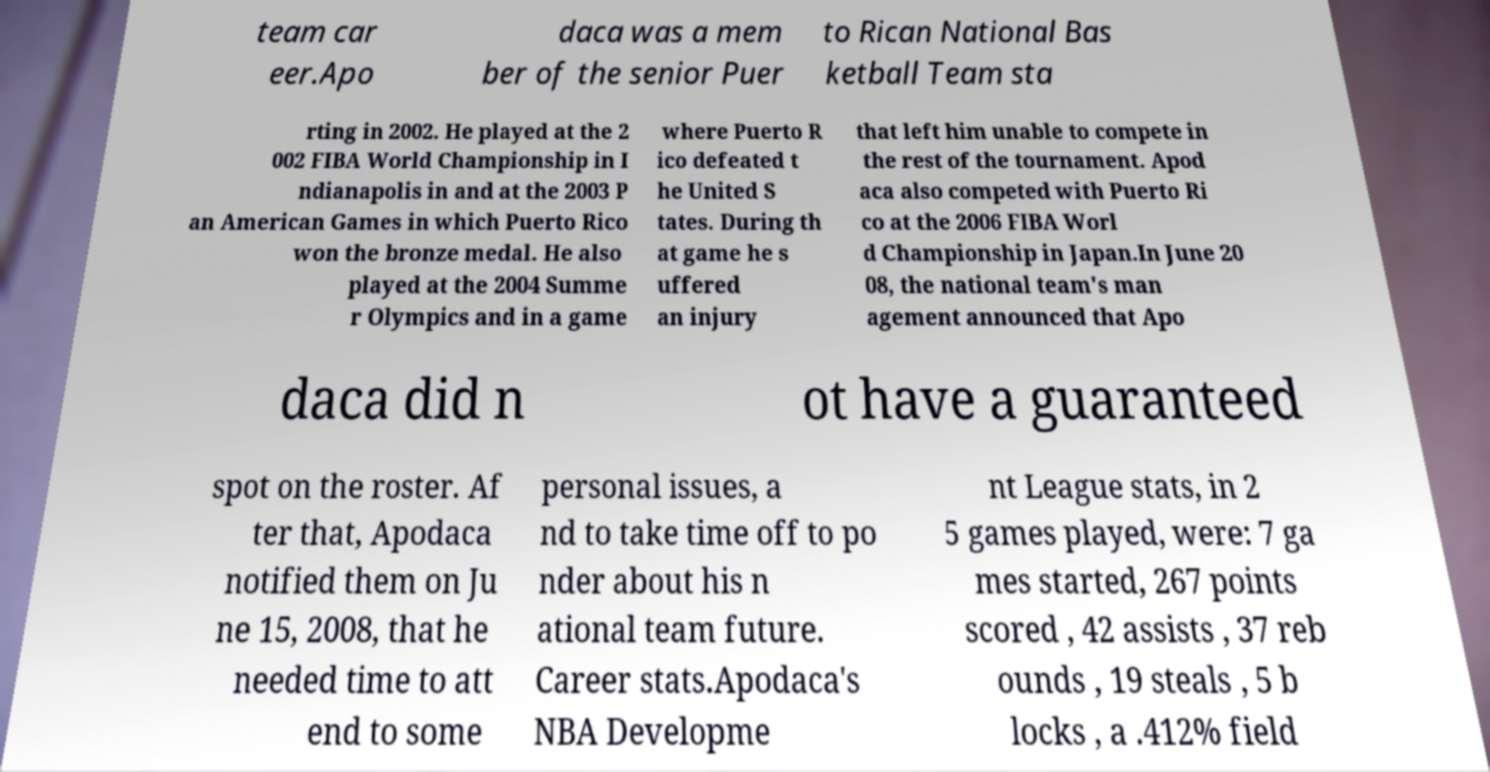What messages or text are displayed in this image? I need them in a readable, typed format. team car eer.Apo daca was a mem ber of the senior Puer to Rican National Bas ketball Team sta rting in 2002. He played at the 2 002 FIBA World Championship in I ndianapolis in and at the 2003 P an American Games in which Puerto Rico won the bronze medal. He also played at the 2004 Summe r Olympics and in a game where Puerto R ico defeated t he United S tates. During th at game he s uffered an injury that left him unable to compete in the rest of the tournament. Apod aca also competed with Puerto Ri co at the 2006 FIBA Worl d Championship in Japan.In June 20 08, the national team's man agement announced that Apo daca did n ot have a guaranteed spot on the roster. Af ter that, Apodaca notified them on Ju ne 15, 2008, that he needed time to att end to some personal issues, a nd to take time off to po nder about his n ational team future. Career stats.Apodaca's NBA Developme nt League stats, in 2 5 games played, were: 7 ga mes started, 267 points scored , 42 assists , 37 reb ounds , 19 steals , 5 b locks , a .412% field 